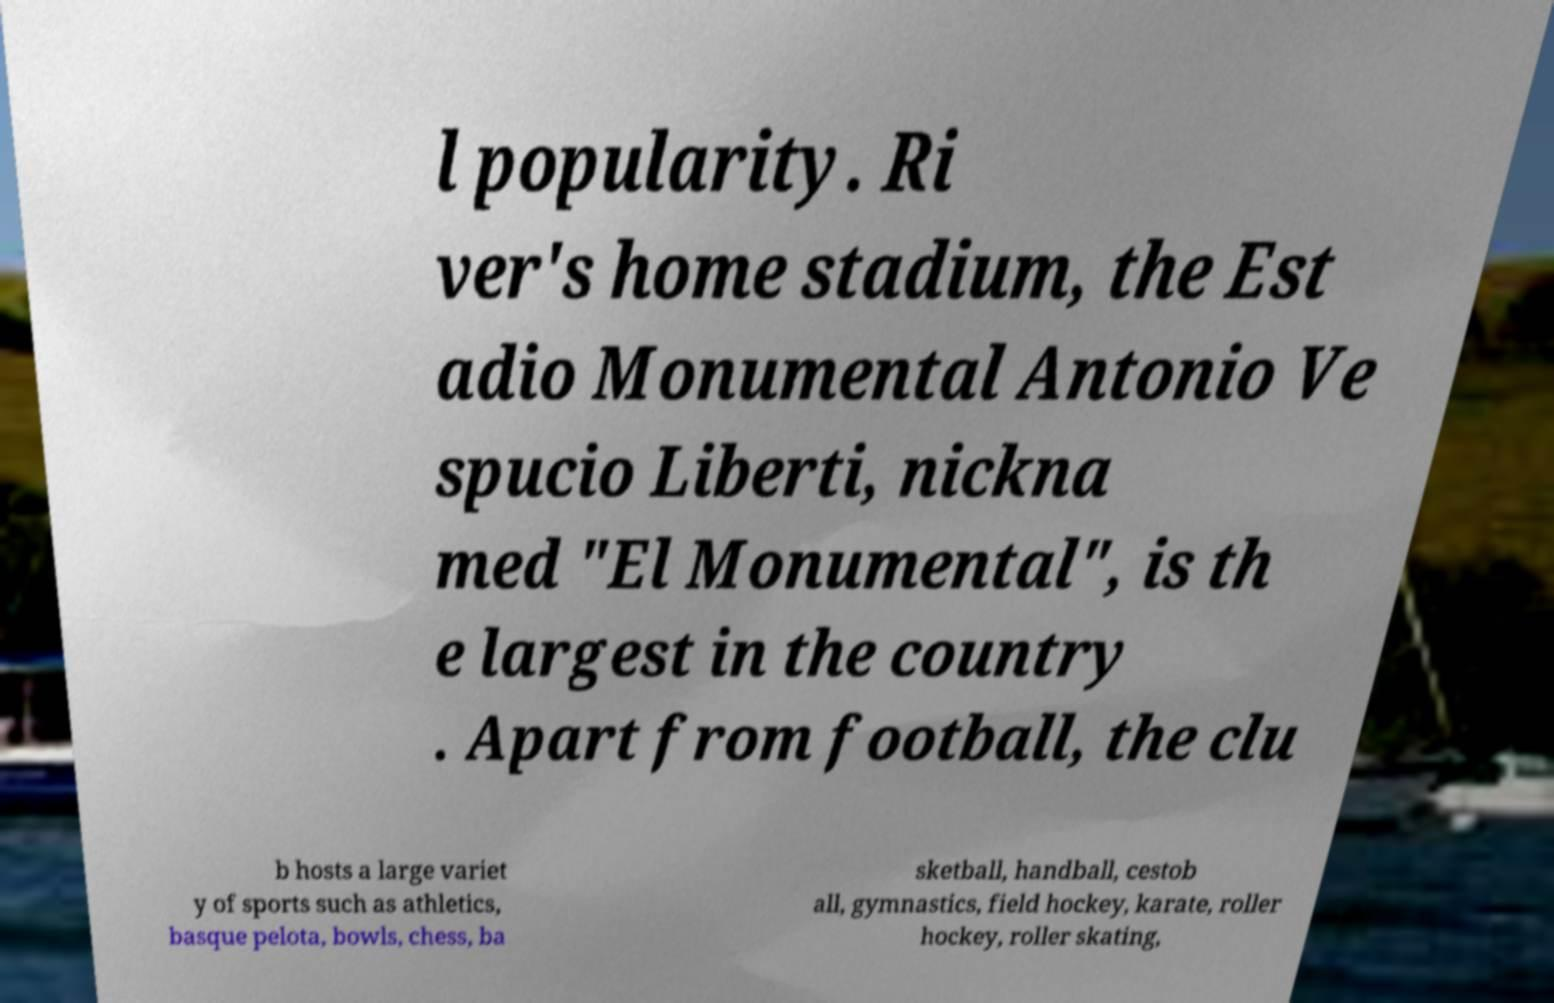I need the written content from this picture converted into text. Can you do that? l popularity. Ri ver's home stadium, the Est adio Monumental Antonio Ve spucio Liberti, nickna med "El Monumental", is th e largest in the country . Apart from football, the clu b hosts a large variet y of sports such as athletics, basque pelota, bowls, chess, ba sketball, handball, cestob all, gymnastics, field hockey, karate, roller hockey, roller skating, 